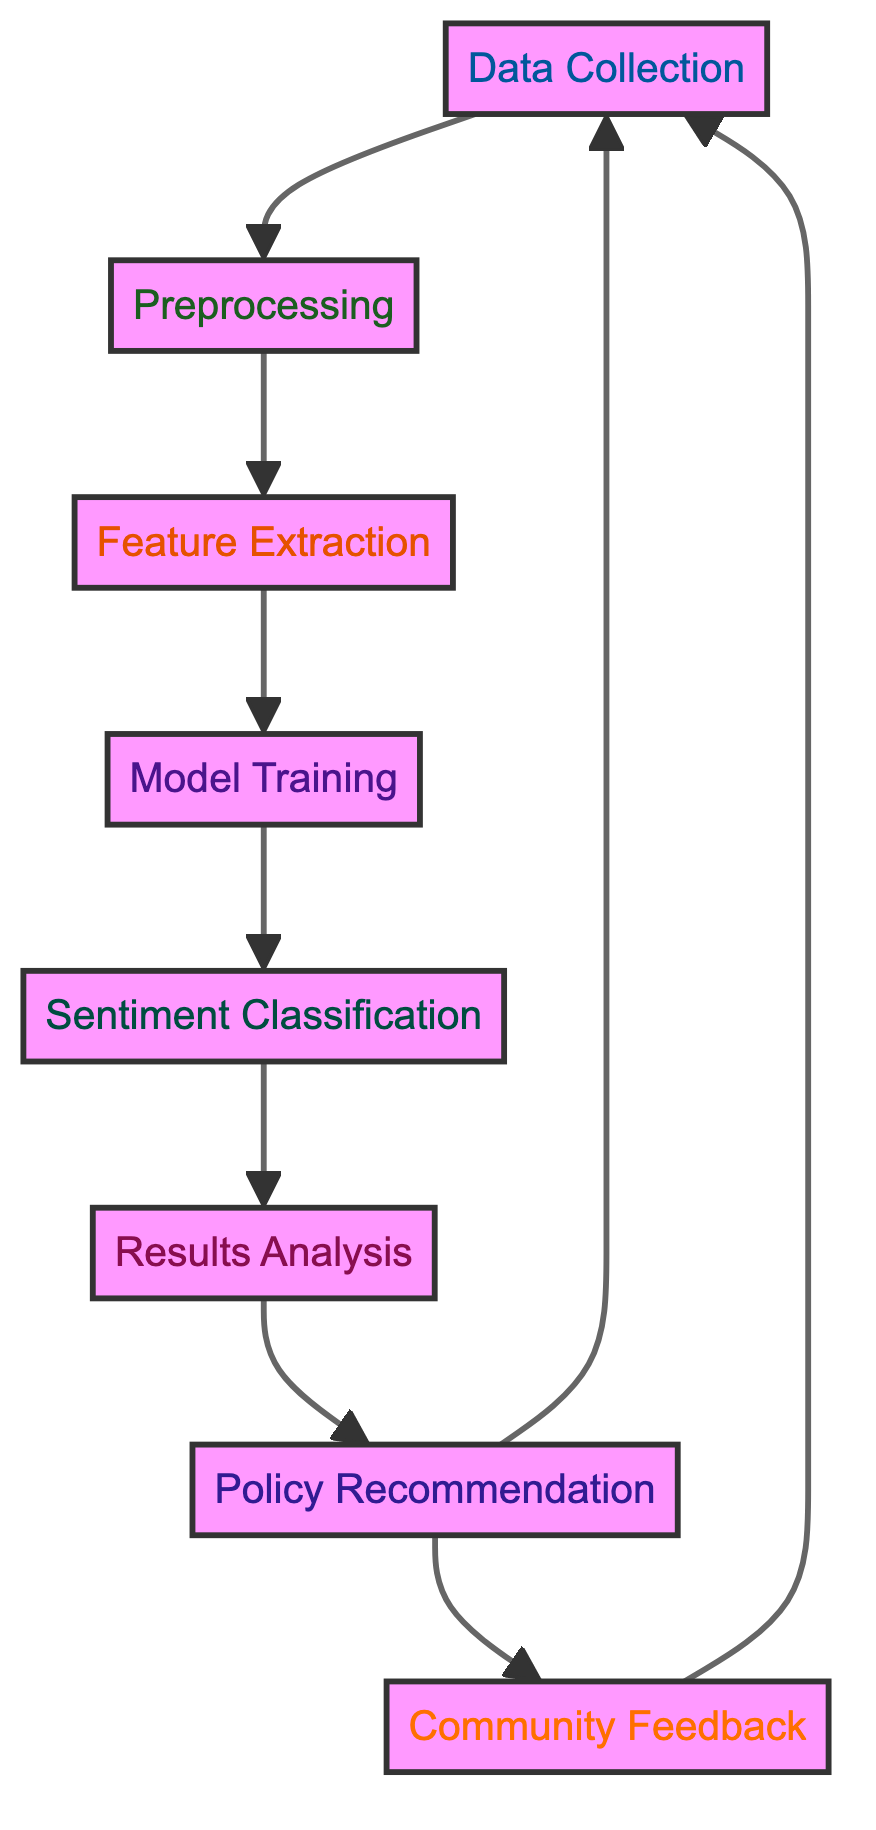What is the first step in the diagram? The first step in the diagram is represented by the node "Data Collection." It is the initial action performed in the machine learning process outlined in the diagram.
Answer: Data Collection How many nodes are present in the diagram? By counting the unique actions represented in the diagram, we find there are eight nodes in total. Each node represents a key step or outcome in the sentiment analysis workflow.
Answer: Eight Which node comes after Feature Extraction? The "Model Training" node follows "Feature Extraction" in the flow, indicating that feature extraction is a prerequisite before the model can be trained on the extracted features.
Answer: Model Training What is the final outcome in the diagram? The last process represented in the diagram is "Community Feedback," indicating that it is an integral part of the feedback loop that informs the ongoing collection of data and analysis.
Answer: Community Feedback What connects Policy Recommendation to its preceding node? The arrow connecting "Policy Recommendation" to "Results Analysis" indicates that recommendations are based on the outcomes analyzed from the sentiment classification process.
Answer: Results Analysis Explain the relationship between Sentiment Classification and Results Analysis. "Sentiment Classification" is the process that results from "Model Training" and feeds directly into "Results Analysis." The classification is essential to understand sentiments in community feedback, which are then analyzed for insights.
Answer: Directly connected How do results influence community feedback according to the diagram? The diagram indicates that "Results Analysis" leads to "Policy Recommendation" and contributes to "Community Feedback." This implies that analyzed results are used to craft recommendations, which invite further community engagement and feedback.
Answer: Through Policy Recommendation What type of feedback does the diagram ultimately aim to analyze? The diagram focuses on analyzing community feedback concerning educational programs, reflecting the overall goal of improving such programs based on the sentiments derived from the data collected.
Answer: Educational Programs 